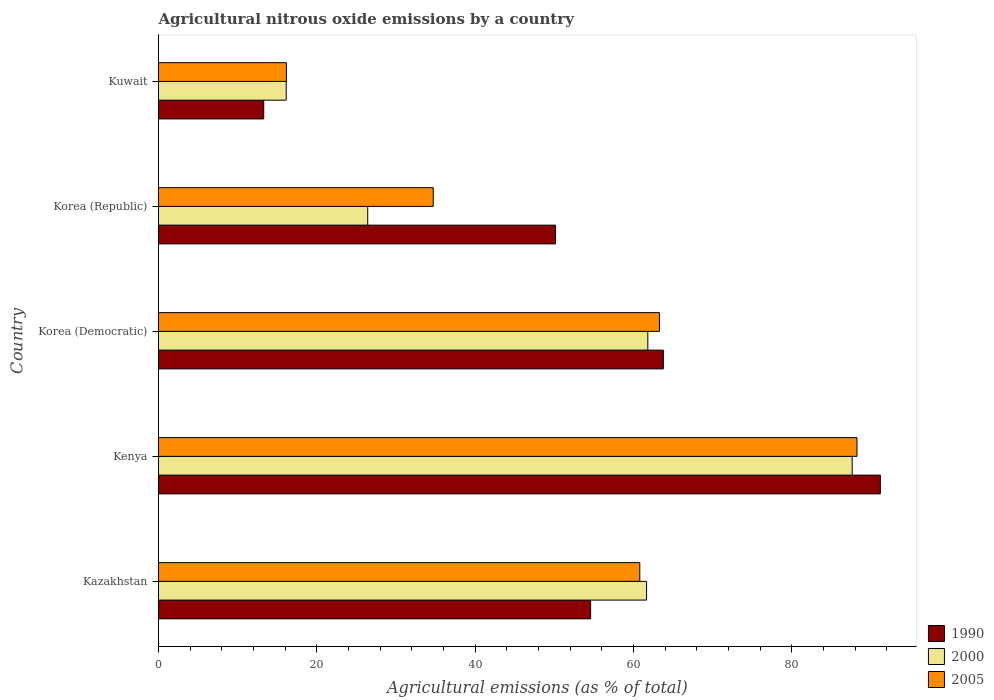How many groups of bars are there?
Keep it short and to the point. 5. How many bars are there on the 4th tick from the top?
Your response must be concise. 3. What is the label of the 3rd group of bars from the top?
Make the answer very short. Korea (Democratic). What is the amount of agricultural nitrous oxide emitted in 1990 in Korea (Democratic)?
Your answer should be compact. 63.78. Across all countries, what is the maximum amount of agricultural nitrous oxide emitted in 2005?
Offer a very short reply. 88.25. Across all countries, what is the minimum amount of agricultural nitrous oxide emitted in 2000?
Provide a short and direct response. 16.13. In which country was the amount of agricultural nitrous oxide emitted in 1990 maximum?
Your answer should be very brief. Kenya. In which country was the amount of agricultural nitrous oxide emitted in 2000 minimum?
Keep it short and to the point. Kuwait. What is the total amount of agricultural nitrous oxide emitted in 2000 in the graph?
Provide a succinct answer. 253.7. What is the difference between the amount of agricultural nitrous oxide emitted in 2005 in Kenya and that in Kuwait?
Your response must be concise. 72.09. What is the difference between the amount of agricultural nitrous oxide emitted in 1990 in Korea (Democratic) and the amount of agricultural nitrous oxide emitted in 2000 in Korea (Republic)?
Provide a succinct answer. 37.35. What is the average amount of agricultural nitrous oxide emitted in 2005 per country?
Offer a terse response. 52.64. What is the difference between the amount of agricultural nitrous oxide emitted in 1990 and amount of agricultural nitrous oxide emitted in 2000 in Kenya?
Keep it short and to the point. 3.55. In how many countries, is the amount of agricultural nitrous oxide emitted in 2000 greater than 72 %?
Give a very brief answer. 1. What is the ratio of the amount of agricultural nitrous oxide emitted in 2000 in Kenya to that in Korea (Republic)?
Make the answer very short. 3.32. What is the difference between the highest and the second highest amount of agricultural nitrous oxide emitted in 2000?
Provide a short and direct response. 25.82. What is the difference between the highest and the lowest amount of agricultural nitrous oxide emitted in 1990?
Give a very brief answer. 77.91. In how many countries, is the amount of agricultural nitrous oxide emitted in 2005 greater than the average amount of agricultural nitrous oxide emitted in 2005 taken over all countries?
Provide a short and direct response. 3. What does the 3rd bar from the bottom in Kenya represents?
Keep it short and to the point. 2005. How many bars are there?
Ensure brevity in your answer.  15. Are all the bars in the graph horizontal?
Ensure brevity in your answer.  Yes. How many countries are there in the graph?
Ensure brevity in your answer.  5. Are the values on the major ticks of X-axis written in scientific E-notation?
Your answer should be compact. No. Does the graph contain any zero values?
Give a very brief answer. No. How are the legend labels stacked?
Offer a terse response. Vertical. What is the title of the graph?
Give a very brief answer. Agricultural nitrous oxide emissions by a country. What is the label or title of the X-axis?
Your answer should be very brief. Agricultural emissions (as % of total). What is the label or title of the Y-axis?
Provide a succinct answer. Country. What is the Agricultural emissions (as % of total) of 1990 in Kazakhstan?
Your answer should be compact. 54.6. What is the Agricultural emissions (as % of total) of 2000 in Kazakhstan?
Your answer should be compact. 61.66. What is the Agricultural emissions (as % of total) in 2005 in Kazakhstan?
Keep it short and to the point. 60.81. What is the Agricultural emissions (as % of total) in 1990 in Kenya?
Give a very brief answer. 91.2. What is the Agricultural emissions (as % of total) of 2000 in Kenya?
Provide a succinct answer. 87.65. What is the Agricultural emissions (as % of total) of 2005 in Kenya?
Offer a very short reply. 88.25. What is the Agricultural emissions (as % of total) of 1990 in Korea (Democratic)?
Keep it short and to the point. 63.78. What is the Agricultural emissions (as % of total) in 2000 in Korea (Democratic)?
Keep it short and to the point. 61.82. What is the Agricultural emissions (as % of total) in 2005 in Korea (Democratic)?
Provide a short and direct response. 63.29. What is the Agricultural emissions (as % of total) of 1990 in Korea (Republic)?
Make the answer very short. 50.16. What is the Agricultural emissions (as % of total) of 2000 in Korea (Republic)?
Your answer should be very brief. 26.43. What is the Agricultural emissions (as % of total) of 2005 in Korea (Republic)?
Give a very brief answer. 34.71. What is the Agricultural emissions (as % of total) in 1990 in Kuwait?
Keep it short and to the point. 13.29. What is the Agricultural emissions (as % of total) in 2000 in Kuwait?
Your answer should be compact. 16.13. What is the Agricultural emissions (as % of total) of 2005 in Kuwait?
Provide a succinct answer. 16.16. Across all countries, what is the maximum Agricultural emissions (as % of total) in 1990?
Your response must be concise. 91.2. Across all countries, what is the maximum Agricultural emissions (as % of total) in 2000?
Give a very brief answer. 87.65. Across all countries, what is the maximum Agricultural emissions (as % of total) of 2005?
Keep it short and to the point. 88.25. Across all countries, what is the minimum Agricultural emissions (as % of total) of 1990?
Make the answer very short. 13.29. Across all countries, what is the minimum Agricultural emissions (as % of total) in 2000?
Your response must be concise. 16.13. Across all countries, what is the minimum Agricultural emissions (as % of total) of 2005?
Offer a terse response. 16.16. What is the total Agricultural emissions (as % of total) of 1990 in the graph?
Offer a very short reply. 273.03. What is the total Agricultural emissions (as % of total) of 2000 in the graph?
Offer a terse response. 253.7. What is the total Agricultural emissions (as % of total) in 2005 in the graph?
Make the answer very short. 263.21. What is the difference between the Agricultural emissions (as % of total) of 1990 in Kazakhstan and that in Kenya?
Make the answer very short. -36.6. What is the difference between the Agricultural emissions (as % of total) of 2000 in Kazakhstan and that in Kenya?
Your response must be concise. -25.98. What is the difference between the Agricultural emissions (as % of total) of 2005 in Kazakhstan and that in Kenya?
Keep it short and to the point. -27.44. What is the difference between the Agricultural emissions (as % of total) in 1990 in Kazakhstan and that in Korea (Democratic)?
Your answer should be very brief. -9.19. What is the difference between the Agricultural emissions (as % of total) in 2000 in Kazakhstan and that in Korea (Democratic)?
Keep it short and to the point. -0.16. What is the difference between the Agricultural emissions (as % of total) of 2005 in Kazakhstan and that in Korea (Democratic)?
Provide a short and direct response. -2.48. What is the difference between the Agricultural emissions (as % of total) in 1990 in Kazakhstan and that in Korea (Republic)?
Your answer should be compact. 4.44. What is the difference between the Agricultural emissions (as % of total) in 2000 in Kazakhstan and that in Korea (Republic)?
Provide a succinct answer. 35.23. What is the difference between the Agricultural emissions (as % of total) in 2005 in Kazakhstan and that in Korea (Republic)?
Your answer should be very brief. 26.1. What is the difference between the Agricultural emissions (as % of total) of 1990 in Kazakhstan and that in Kuwait?
Your answer should be compact. 41.3. What is the difference between the Agricultural emissions (as % of total) in 2000 in Kazakhstan and that in Kuwait?
Ensure brevity in your answer.  45.53. What is the difference between the Agricultural emissions (as % of total) of 2005 in Kazakhstan and that in Kuwait?
Keep it short and to the point. 44.65. What is the difference between the Agricultural emissions (as % of total) in 1990 in Kenya and that in Korea (Democratic)?
Offer a very short reply. 27.41. What is the difference between the Agricultural emissions (as % of total) in 2000 in Kenya and that in Korea (Democratic)?
Give a very brief answer. 25.82. What is the difference between the Agricultural emissions (as % of total) of 2005 in Kenya and that in Korea (Democratic)?
Offer a terse response. 24.96. What is the difference between the Agricultural emissions (as % of total) in 1990 in Kenya and that in Korea (Republic)?
Ensure brevity in your answer.  41.04. What is the difference between the Agricultural emissions (as % of total) of 2000 in Kenya and that in Korea (Republic)?
Your answer should be compact. 61.21. What is the difference between the Agricultural emissions (as % of total) in 2005 in Kenya and that in Korea (Republic)?
Your answer should be compact. 53.54. What is the difference between the Agricultural emissions (as % of total) of 1990 in Kenya and that in Kuwait?
Make the answer very short. 77.91. What is the difference between the Agricultural emissions (as % of total) of 2000 in Kenya and that in Kuwait?
Your answer should be very brief. 71.51. What is the difference between the Agricultural emissions (as % of total) of 2005 in Kenya and that in Kuwait?
Your answer should be very brief. 72.09. What is the difference between the Agricultural emissions (as % of total) in 1990 in Korea (Democratic) and that in Korea (Republic)?
Give a very brief answer. 13.62. What is the difference between the Agricultural emissions (as % of total) in 2000 in Korea (Democratic) and that in Korea (Republic)?
Keep it short and to the point. 35.39. What is the difference between the Agricultural emissions (as % of total) in 2005 in Korea (Democratic) and that in Korea (Republic)?
Your answer should be very brief. 28.58. What is the difference between the Agricultural emissions (as % of total) in 1990 in Korea (Democratic) and that in Kuwait?
Keep it short and to the point. 50.49. What is the difference between the Agricultural emissions (as % of total) of 2000 in Korea (Democratic) and that in Kuwait?
Your answer should be compact. 45.69. What is the difference between the Agricultural emissions (as % of total) in 2005 in Korea (Democratic) and that in Kuwait?
Your response must be concise. 47.13. What is the difference between the Agricultural emissions (as % of total) in 1990 in Korea (Republic) and that in Kuwait?
Offer a terse response. 36.87. What is the difference between the Agricultural emissions (as % of total) in 2000 in Korea (Republic) and that in Kuwait?
Make the answer very short. 10.3. What is the difference between the Agricultural emissions (as % of total) of 2005 in Korea (Republic) and that in Kuwait?
Offer a very short reply. 18.55. What is the difference between the Agricultural emissions (as % of total) of 1990 in Kazakhstan and the Agricultural emissions (as % of total) of 2000 in Kenya?
Give a very brief answer. -33.05. What is the difference between the Agricultural emissions (as % of total) of 1990 in Kazakhstan and the Agricultural emissions (as % of total) of 2005 in Kenya?
Make the answer very short. -33.65. What is the difference between the Agricultural emissions (as % of total) of 2000 in Kazakhstan and the Agricultural emissions (as % of total) of 2005 in Kenya?
Ensure brevity in your answer.  -26.58. What is the difference between the Agricultural emissions (as % of total) in 1990 in Kazakhstan and the Agricultural emissions (as % of total) in 2000 in Korea (Democratic)?
Give a very brief answer. -7.23. What is the difference between the Agricultural emissions (as % of total) of 1990 in Kazakhstan and the Agricultural emissions (as % of total) of 2005 in Korea (Democratic)?
Provide a succinct answer. -8.69. What is the difference between the Agricultural emissions (as % of total) of 2000 in Kazakhstan and the Agricultural emissions (as % of total) of 2005 in Korea (Democratic)?
Make the answer very short. -1.62. What is the difference between the Agricultural emissions (as % of total) in 1990 in Kazakhstan and the Agricultural emissions (as % of total) in 2000 in Korea (Republic)?
Offer a very short reply. 28.16. What is the difference between the Agricultural emissions (as % of total) of 1990 in Kazakhstan and the Agricultural emissions (as % of total) of 2005 in Korea (Republic)?
Give a very brief answer. 19.89. What is the difference between the Agricultural emissions (as % of total) of 2000 in Kazakhstan and the Agricultural emissions (as % of total) of 2005 in Korea (Republic)?
Keep it short and to the point. 26.95. What is the difference between the Agricultural emissions (as % of total) of 1990 in Kazakhstan and the Agricultural emissions (as % of total) of 2000 in Kuwait?
Provide a short and direct response. 38.46. What is the difference between the Agricultural emissions (as % of total) of 1990 in Kazakhstan and the Agricultural emissions (as % of total) of 2005 in Kuwait?
Offer a very short reply. 38.44. What is the difference between the Agricultural emissions (as % of total) in 2000 in Kazakhstan and the Agricultural emissions (as % of total) in 2005 in Kuwait?
Your answer should be compact. 45.5. What is the difference between the Agricultural emissions (as % of total) of 1990 in Kenya and the Agricultural emissions (as % of total) of 2000 in Korea (Democratic)?
Your answer should be compact. 29.38. What is the difference between the Agricultural emissions (as % of total) in 1990 in Kenya and the Agricultural emissions (as % of total) in 2005 in Korea (Democratic)?
Give a very brief answer. 27.91. What is the difference between the Agricultural emissions (as % of total) of 2000 in Kenya and the Agricultural emissions (as % of total) of 2005 in Korea (Democratic)?
Make the answer very short. 24.36. What is the difference between the Agricultural emissions (as % of total) in 1990 in Kenya and the Agricultural emissions (as % of total) in 2000 in Korea (Republic)?
Provide a short and direct response. 64.77. What is the difference between the Agricultural emissions (as % of total) in 1990 in Kenya and the Agricultural emissions (as % of total) in 2005 in Korea (Republic)?
Your response must be concise. 56.49. What is the difference between the Agricultural emissions (as % of total) in 2000 in Kenya and the Agricultural emissions (as % of total) in 2005 in Korea (Republic)?
Keep it short and to the point. 52.94. What is the difference between the Agricultural emissions (as % of total) of 1990 in Kenya and the Agricultural emissions (as % of total) of 2000 in Kuwait?
Your answer should be compact. 75.06. What is the difference between the Agricultural emissions (as % of total) in 1990 in Kenya and the Agricultural emissions (as % of total) in 2005 in Kuwait?
Provide a succinct answer. 75.04. What is the difference between the Agricultural emissions (as % of total) of 2000 in Kenya and the Agricultural emissions (as % of total) of 2005 in Kuwait?
Your answer should be very brief. 71.49. What is the difference between the Agricultural emissions (as % of total) in 1990 in Korea (Democratic) and the Agricultural emissions (as % of total) in 2000 in Korea (Republic)?
Ensure brevity in your answer.  37.35. What is the difference between the Agricultural emissions (as % of total) of 1990 in Korea (Democratic) and the Agricultural emissions (as % of total) of 2005 in Korea (Republic)?
Your answer should be very brief. 29.08. What is the difference between the Agricultural emissions (as % of total) in 2000 in Korea (Democratic) and the Agricultural emissions (as % of total) in 2005 in Korea (Republic)?
Offer a very short reply. 27.11. What is the difference between the Agricultural emissions (as % of total) of 1990 in Korea (Democratic) and the Agricultural emissions (as % of total) of 2000 in Kuwait?
Ensure brevity in your answer.  47.65. What is the difference between the Agricultural emissions (as % of total) in 1990 in Korea (Democratic) and the Agricultural emissions (as % of total) in 2005 in Kuwait?
Your answer should be very brief. 47.63. What is the difference between the Agricultural emissions (as % of total) of 2000 in Korea (Democratic) and the Agricultural emissions (as % of total) of 2005 in Kuwait?
Your answer should be very brief. 45.66. What is the difference between the Agricultural emissions (as % of total) in 1990 in Korea (Republic) and the Agricultural emissions (as % of total) in 2000 in Kuwait?
Ensure brevity in your answer.  34.03. What is the difference between the Agricultural emissions (as % of total) of 1990 in Korea (Republic) and the Agricultural emissions (as % of total) of 2005 in Kuwait?
Your response must be concise. 34. What is the difference between the Agricultural emissions (as % of total) of 2000 in Korea (Republic) and the Agricultural emissions (as % of total) of 2005 in Kuwait?
Your answer should be very brief. 10.27. What is the average Agricultural emissions (as % of total) of 1990 per country?
Offer a very short reply. 54.61. What is the average Agricultural emissions (as % of total) in 2000 per country?
Your answer should be compact. 50.74. What is the average Agricultural emissions (as % of total) in 2005 per country?
Your answer should be very brief. 52.64. What is the difference between the Agricultural emissions (as % of total) of 1990 and Agricultural emissions (as % of total) of 2000 in Kazakhstan?
Make the answer very short. -7.07. What is the difference between the Agricultural emissions (as % of total) of 1990 and Agricultural emissions (as % of total) of 2005 in Kazakhstan?
Provide a short and direct response. -6.21. What is the difference between the Agricultural emissions (as % of total) in 2000 and Agricultural emissions (as % of total) in 2005 in Kazakhstan?
Give a very brief answer. 0.86. What is the difference between the Agricultural emissions (as % of total) in 1990 and Agricultural emissions (as % of total) in 2000 in Kenya?
Provide a succinct answer. 3.55. What is the difference between the Agricultural emissions (as % of total) in 1990 and Agricultural emissions (as % of total) in 2005 in Kenya?
Keep it short and to the point. 2.95. What is the difference between the Agricultural emissions (as % of total) of 2000 and Agricultural emissions (as % of total) of 2005 in Kenya?
Your answer should be compact. -0.6. What is the difference between the Agricultural emissions (as % of total) in 1990 and Agricultural emissions (as % of total) in 2000 in Korea (Democratic)?
Your answer should be compact. 1.96. What is the difference between the Agricultural emissions (as % of total) of 1990 and Agricultural emissions (as % of total) of 2005 in Korea (Democratic)?
Make the answer very short. 0.5. What is the difference between the Agricultural emissions (as % of total) of 2000 and Agricultural emissions (as % of total) of 2005 in Korea (Democratic)?
Provide a succinct answer. -1.47. What is the difference between the Agricultural emissions (as % of total) in 1990 and Agricultural emissions (as % of total) in 2000 in Korea (Republic)?
Your response must be concise. 23.73. What is the difference between the Agricultural emissions (as % of total) of 1990 and Agricultural emissions (as % of total) of 2005 in Korea (Republic)?
Give a very brief answer. 15.45. What is the difference between the Agricultural emissions (as % of total) in 2000 and Agricultural emissions (as % of total) in 2005 in Korea (Republic)?
Offer a very short reply. -8.28. What is the difference between the Agricultural emissions (as % of total) in 1990 and Agricultural emissions (as % of total) in 2000 in Kuwait?
Your answer should be very brief. -2.84. What is the difference between the Agricultural emissions (as % of total) of 1990 and Agricultural emissions (as % of total) of 2005 in Kuwait?
Give a very brief answer. -2.87. What is the difference between the Agricultural emissions (as % of total) in 2000 and Agricultural emissions (as % of total) in 2005 in Kuwait?
Your answer should be compact. -0.02. What is the ratio of the Agricultural emissions (as % of total) in 1990 in Kazakhstan to that in Kenya?
Give a very brief answer. 0.6. What is the ratio of the Agricultural emissions (as % of total) of 2000 in Kazakhstan to that in Kenya?
Keep it short and to the point. 0.7. What is the ratio of the Agricultural emissions (as % of total) in 2005 in Kazakhstan to that in Kenya?
Keep it short and to the point. 0.69. What is the ratio of the Agricultural emissions (as % of total) in 1990 in Kazakhstan to that in Korea (Democratic)?
Provide a succinct answer. 0.86. What is the ratio of the Agricultural emissions (as % of total) in 2000 in Kazakhstan to that in Korea (Democratic)?
Your answer should be compact. 1. What is the ratio of the Agricultural emissions (as % of total) in 2005 in Kazakhstan to that in Korea (Democratic)?
Your answer should be very brief. 0.96. What is the ratio of the Agricultural emissions (as % of total) of 1990 in Kazakhstan to that in Korea (Republic)?
Your response must be concise. 1.09. What is the ratio of the Agricultural emissions (as % of total) of 2000 in Kazakhstan to that in Korea (Republic)?
Offer a very short reply. 2.33. What is the ratio of the Agricultural emissions (as % of total) in 2005 in Kazakhstan to that in Korea (Republic)?
Offer a terse response. 1.75. What is the ratio of the Agricultural emissions (as % of total) of 1990 in Kazakhstan to that in Kuwait?
Ensure brevity in your answer.  4.11. What is the ratio of the Agricultural emissions (as % of total) in 2000 in Kazakhstan to that in Kuwait?
Give a very brief answer. 3.82. What is the ratio of the Agricultural emissions (as % of total) of 2005 in Kazakhstan to that in Kuwait?
Keep it short and to the point. 3.76. What is the ratio of the Agricultural emissions (as % of total) of 1990 in Kenya to that in Korea (Democratic)?
Offer a very short reply. 1.43. What is the ratio of the Agricultural emissions (as % of total) of 2000 in Kenya to that in Korea (Democratic)?
Keep it short and to the point. 1.42. What is the ratio of the Agricultural emissions (as % of total) of 2005 in Kenya to that in Korea (Democratic)?
Your response must be concise. 1.39. What is the ratio of the Agricultural emissions (as % of total) of 1990 in Kenya to that in Korea (Republic)?
Provide a short and direct response. 1.82. What is the ratio of the Agricultural emissions (as % of total) of 2000 in Kenya to that in Korea (Republic)?
Provide a succinct answer. 3.32. What is the ratio of the Agricultural emissions (as % of total) in 2005 in Kenya to that in Korea (Republic)?
Provide a short and direct response. 2.54. What is the ratio of the Agricultural emissions (as % of total) in 1990 in Kenya to that in Kuwait?
Provide a succinct answer. 6.86. What is the ratio of the Agricultural emissions (as % of total) in 2000 in Kenya to that in Kuwait?
Make the answer very short. 5.43. What is the ratio of the Agricultural emissions (as % of total) of 2005 in Kenya to that in Kuwait?
Your response must be concise. 5.46. What is the ratio of the Agricultural emissions (as % of total) of 1990 in Korea (Democratic) to that in Korea (Republic)?
Ensure brevity in your answer.  1.27. What is the ratio of the Agricultural emissions (as % of total) in 2000 in Korea (Democratic) to that in Korea (Republic)?
Your answer should be very brief. 2.34. What is the ratio of the Agricultural emissions (as % of total) of 2005 in Korea (Democratic) to that in Korea (Republic)?
Your answer should be very brief. 1.82. What is the ratio of the Agricultural emissions (as % of total) in 1990 in Korea (Democratic) to that in Kuwait?
Provide a short and direct response. 4.8. What is the ratio of the Agricultural emissions (as % of total) in 2000 in Korea (Democratic) to that in Kuwait?
Offer a terse response. 3.83. What is the ratio of the Agricultural emissions (as % of total) in 2005 in Korea (Democratic) to that in Kuwait?
Provide a short and direct response. 3.92. What is the ratio of the Agricultural emissions (as % of total) of 1990 in Korea (Republic) to that in Kuwait?
Provide a short and direct response. 3.77. What is the ratio of the Agricultural emissions (as % of total) in 2000 in Korea (Republic) to that in Kuwait?
Make the answer very short. 1.64. What is the ratio of the Agricultural emissions (as % of total) in 2005 in Korea (Republic) to that in Kuwait?
Your answer should be compact. 2.15. What is the difference between the highest and the second highest Agricultural emissions (as % of total) of 1990?
Give a very brief answer. 27.41. What is the difference between the highest and the second highest Agricultural emissions (as % of total) of 2000?
Keep it short and to the point. 25.82. What is the difference between the highest and the second highest Agricultural emissions (as % of total) of 2005?
Your response must be concise. 24.96. What is the difference between the highest and the lowest Agricultural emissions (as % of total) in 1990?
Give a very brief answer. 77.91. What is the difference between the highest and the lowest Agricultural emissions (as % of total) of 2000?
Your answer should be very brief. 71.51. What is the difference between the highest and the lowest Agricultural emissions (as % of total) of 2005?
Keep it short and to the point. 72.09. 